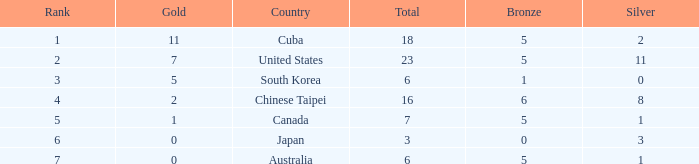What was the sum of the ranks for Japan who had less than 5 bronze medals and more than 3 silvers? None. 